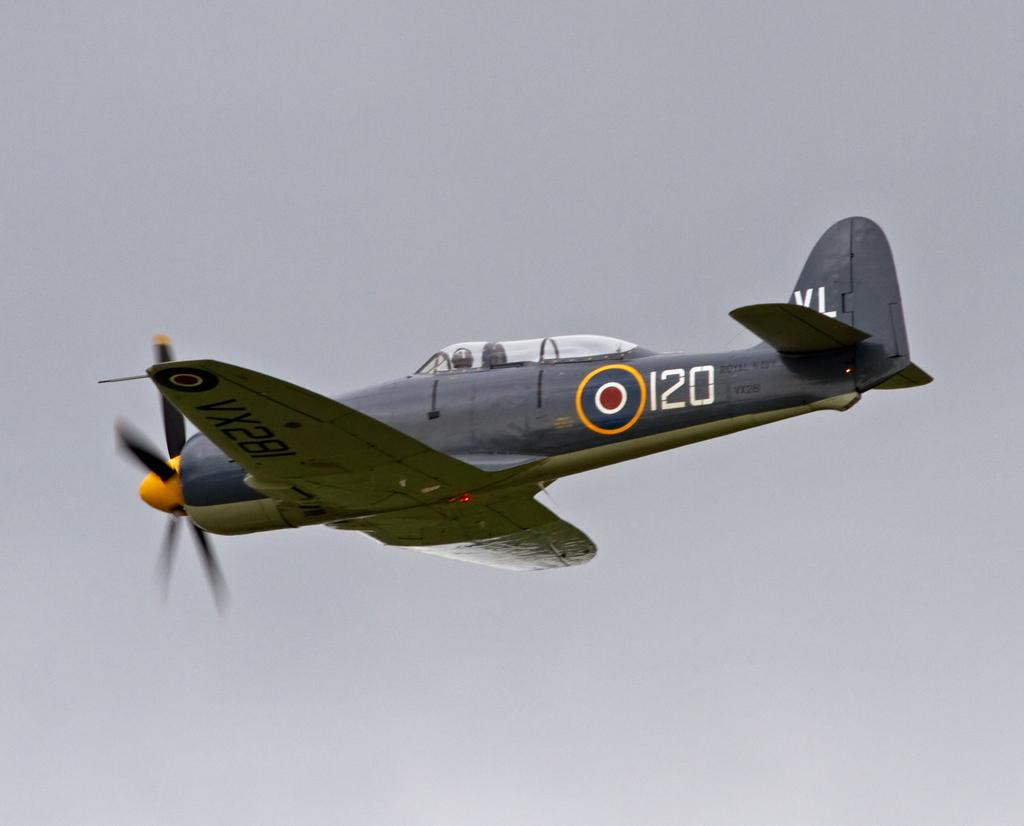What is the plane number?
Provide a succinct answer. 120. What's the plane's identification number?
Give a very brief answer. 120. 